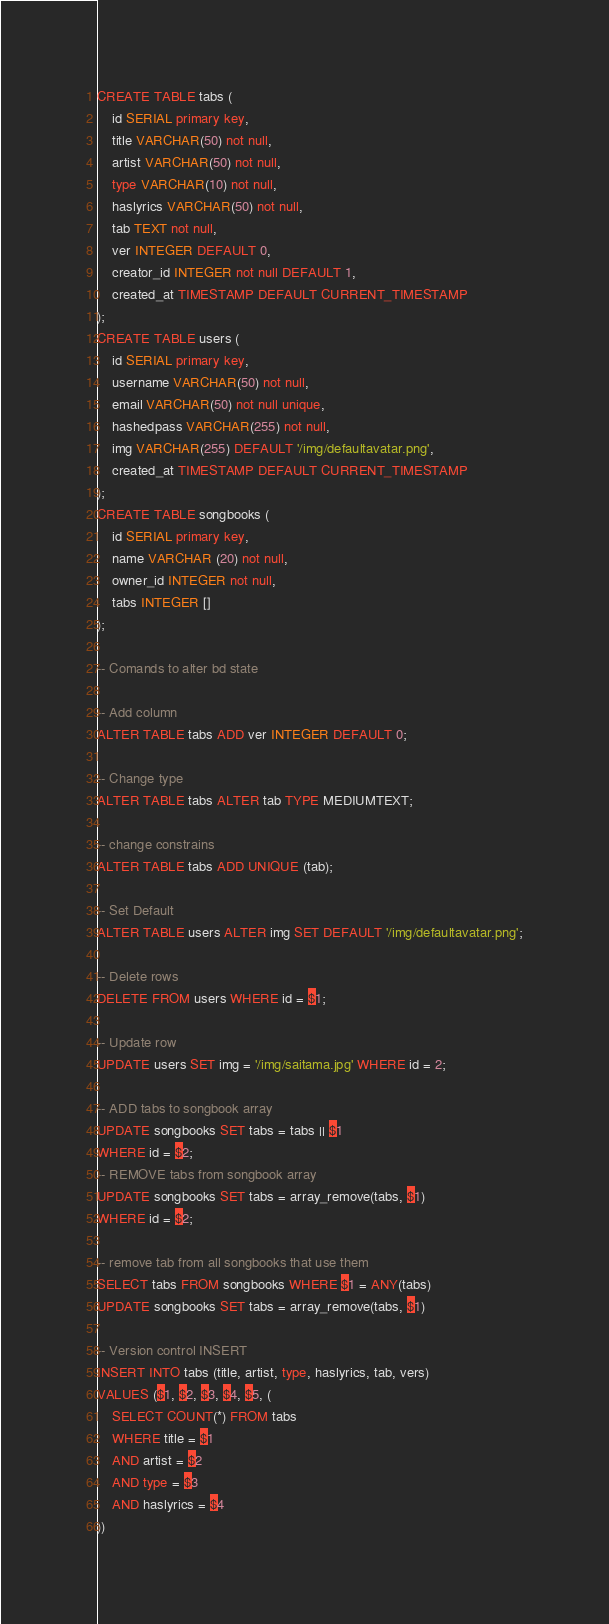<code> <loc_0><loc_0><loc_500><loc_500><_SQL_>CREATE TABLE tabs (
    id SERIAL primary key,
    title VARCHAR(50) not null,
    artist VARCHAR(50) not null,
    type VARCHAR(10) not null,
    haslyrics VARCHAR(50) not null,
    tab TEXT not null,
    ver INTEGER DEFAULT 0,
    creator_id INTEGER not null DEFAULT 1,
    created_at TIMESTAMP DEFAULT CURRENT_TIMESTAMP
);
CREATE TABLE users (
    id SERIAL primary key,
    username VARCHAR(50) not null,
    email VARCHAR(50) not null unique,
    hashedpass VARCHAR(255) not null,
    img VARCHAR(255) DEFAULT '/img/defaultavatar.png',
    created_at TIMESTAMP DEFAULT CURRENT_TIMESTAMP
);
CREATE TABLE songbooks (
    id SERIAL primary key,
    name VARCHAR (20) not null,
    owner_id INTEGER not null,
    tabs INTEGER []
);

-- Comands to alter bd state

-- Add column
ALTER TABLE tabs ADD ver INTEGER DEFAULT 0;

-- Change type
ALTER TABLE tabs ALTER tab TYPE MEDIUMTEXT;

-- change constrains
ALTER TABLE tabs ADD UNIQUE (tab);

-- Set Default
ALTER TABLE users ALTER img SET DEFAULT '/img/defaultavatar.png';

-- Delete rows
DELETE FROM users WHERE id = $1;

-- Update row
UPDATE users SET img = '/img/saitama.jpg' WHERE id = 2;

-- ADD tabs to songbook array
UPDATE songbooks SET tabs = tabs || $1
WHERE id = $2;
-- REMOVE tabs from songbook array
UPDATE songbooks SET tabs = array_remove(tabs, $1)
WHERE id = $2;

-- remove tab from all songbooks that use them
SELECT tabs FROM songbooks WHERE $1 = ANY(tabs)
UPDATE songbooks SET tabs = array_remove(tabs, $1)

-- Version control INSERT
INSERT INTO tabs (title, artist, type, haslyrics, tab, vers)
VALUES ($1, $2, $3, $4, $5, (
    SELECT COUNT(*) FROM tabs
    WHERE title = $1
    AND artist = $2
    AND type = $3
    AND haslyrics = $4
))
</code> 